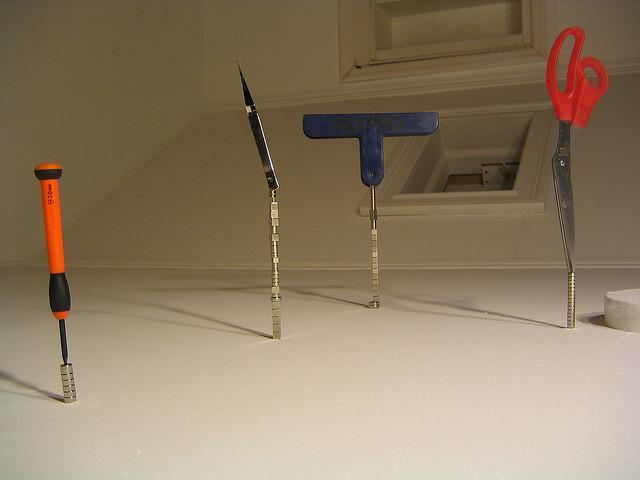How many people are standing in this photo?
Give a very brief answer. 0. 